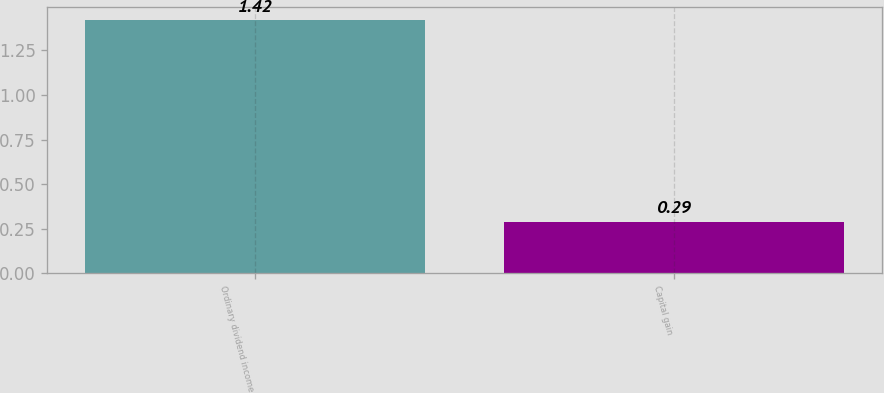Convert chart to OTSL. <chart><loc_0><loc_0><loc_500><loc_500><bar_chart><fcel>Ordinary dividend income<fcel>Capital gain<nl><fcel>1.42<fcel>0.29<nl></chart> 